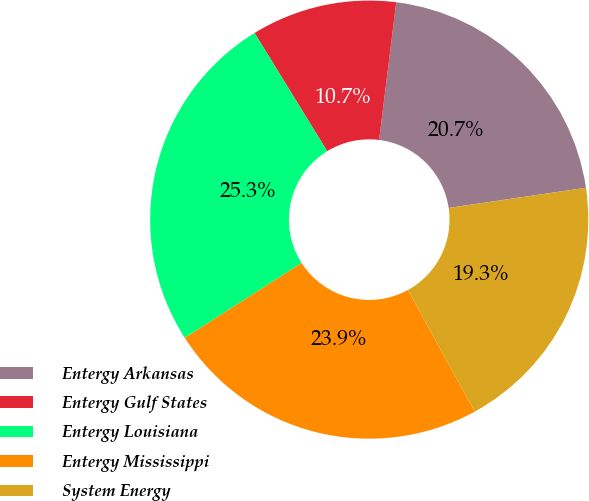<chart> <loc_0><loc_0><loc_500><loc_500><pie_chart><fcel>Entergy Arkansas<fcel>Entergy Gulf States<fcel>Entergy Louisiana<fcel>Entergy Mississippi<fcel>System Energy<nl><fcel>20.71%<fcel>10.74%<fcel>25.31%<fcel>23.93%<fcel>19.33%<nl></chart> 